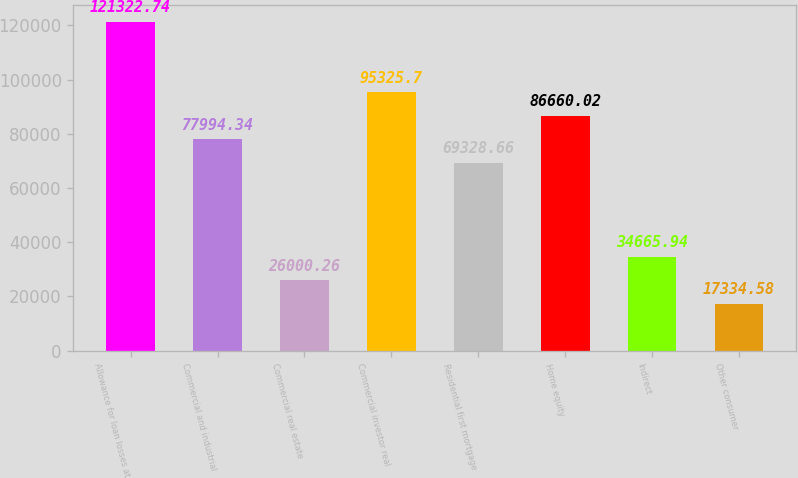Convert chart. <chart><loc_0><loc_0><loc_500><loc_500><bar_chart><fcel>Allowance for loan losses at<fcel>Commercial and industrial<fcel>Commercial real estate<fcel>Commercial investor real<fcel>Residential first mortgage<fcel>Home equity<fcel>Indirect<fcel>Other consumer<nl><fcel>121323<fcel>77994.3<fcel>26000.3<fcel>95325.7<fcel>69328.7<fcel>86660<fcel>34665.9<fcel>17334.6<nl></chart> 